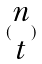Convert formula to latex. <formula><loc_0><loc_0><loc_500><loc_500>( \begin{matrix} n \\ t \end{matrix} )</formula> 